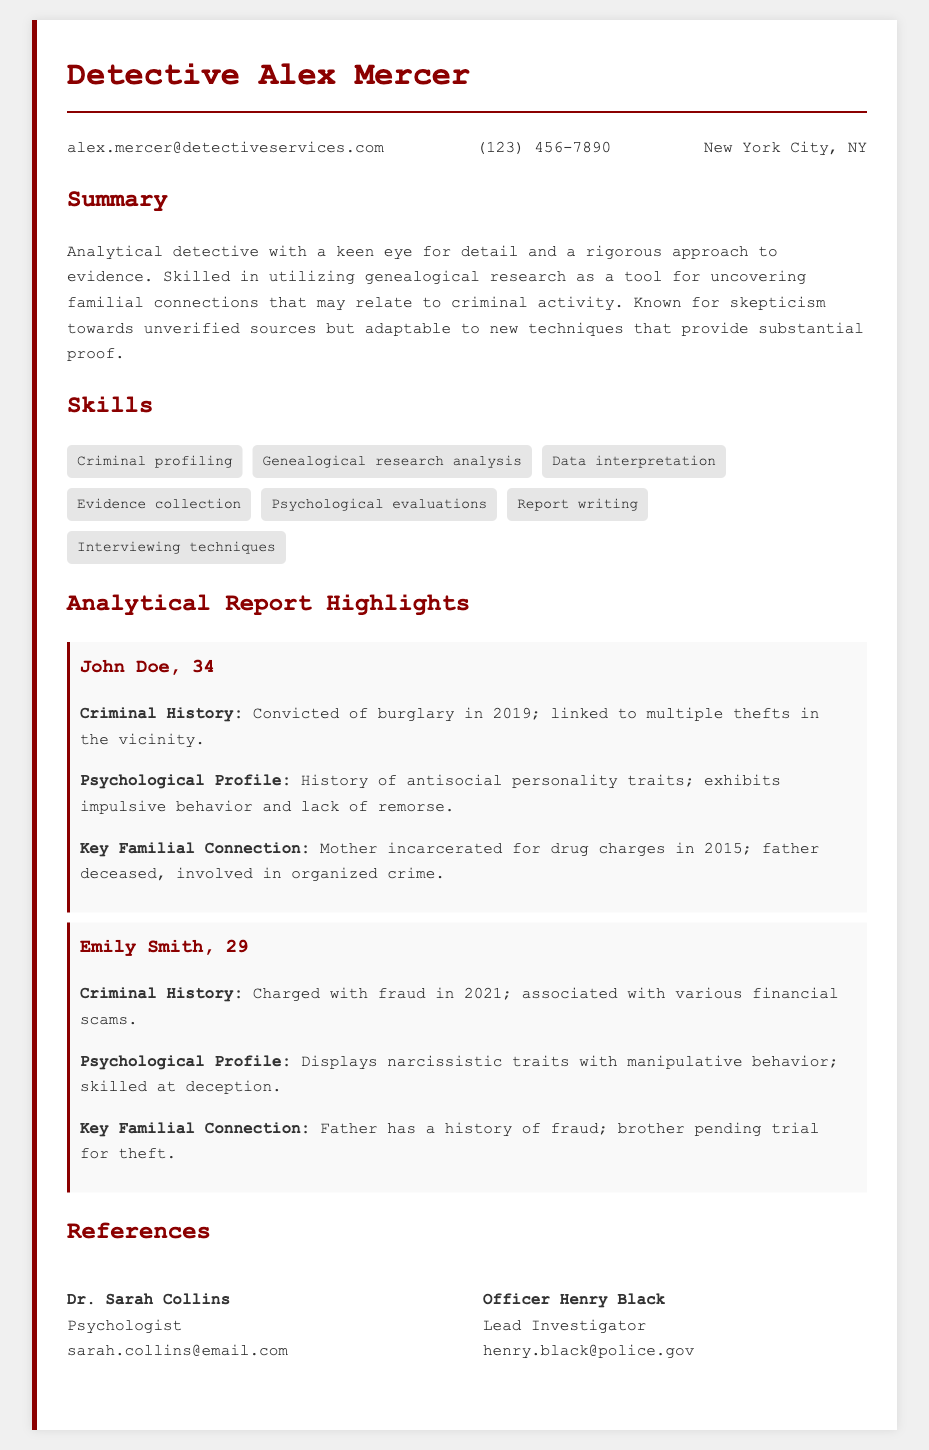What is the name of the detective? The name of the detective is prominently displayed at the top of the document.
Answer: Detective Alex Mercer What is the age of John Doe? John Doe's age is explicitly mentioned in the analytical report highlights section.
Answer: 34 What crime was Emily Smith charged with? The specific charge against Emily Smith is stated under her criminal history.
Answer: Fraud Who is the lead investigator? The name and title of the lead investigator are included in the references section of the document.
Answer: Officer Henry Black What psychological traits are associated with John Doe? This information is found in the psychological profile section related to John Doe.
Answer: Antisocial personality traits What year was John Doe convicted of burglary? The year of John Doe's conviction is noted in the criminal history section.
Answer: 2019 What is one key familial connection of Emily Smith? This detail can be found in the section detailing familial connections related to Emily Smith.
Answer: Father has a history of fraud How many suspects are highlighted in the analytical report? The number of suspects is derived from the report highlights section, where each suspect is listed.
Answer: 2 